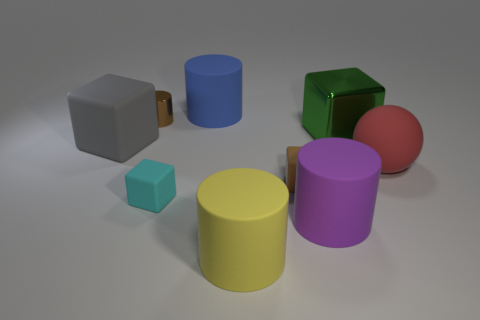Subtract 1 cubes. How many cubes are left? 3 Subtract all cubes. How many objects are left? 5 Subtract all big blue matte objects. Subtract all tiny cyan objects. How many objects are left? 7 Add 1 yellow matte cylinders. How many yellow matte cylinders are left? 2 Add 6 big spheres. How many big spheres exist? 7 Subtract 1 cyan cubes. How many objects are left? 8 